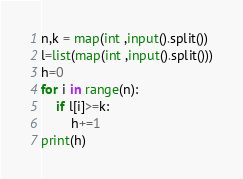<code> <loc_0><loc_0><loc_500><loc_500><_Python_>n,k = map(int ,input().split())
l=list(map(int ,input().split()))
h=0
for i in range(n):
    if l[i]>=k:
        h+=1
print(h)       </code> 